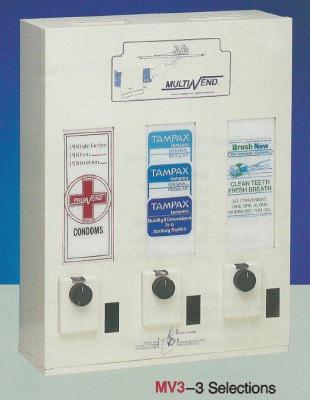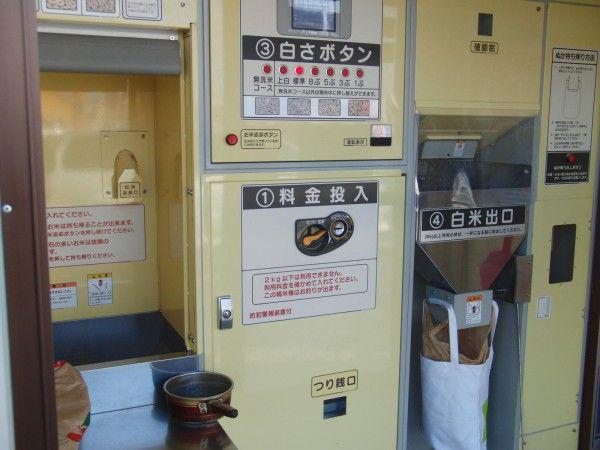The first image is the image on the left, the second image is the image on the right. Given the left and right images, does the statement "One of the vending machines sells condoms." hold true? Answer yes or no. Yes. The first image is the image on the left, the second image is the image on the right. For the images displayed, is the sentence "One of the machines has a red cross on it." factually correct? Answer yes or no. Yes. 